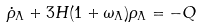<formula> <loc_0><loc_0><loc_500><loc_500>\dot { \rho } _ { \Lambda } + 3 H ( 1 + \omega _ { \Lambda } ) \rho _ { \Lambda } = - Q</formula> 